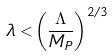Convert formula to latex. <formula><loc_0><loc_0><loc_500><loc_500>\lambda < \left ( \frac { \Lambda } { M _ { P } } \right ) ^ { 2 / 3 }</formula> 